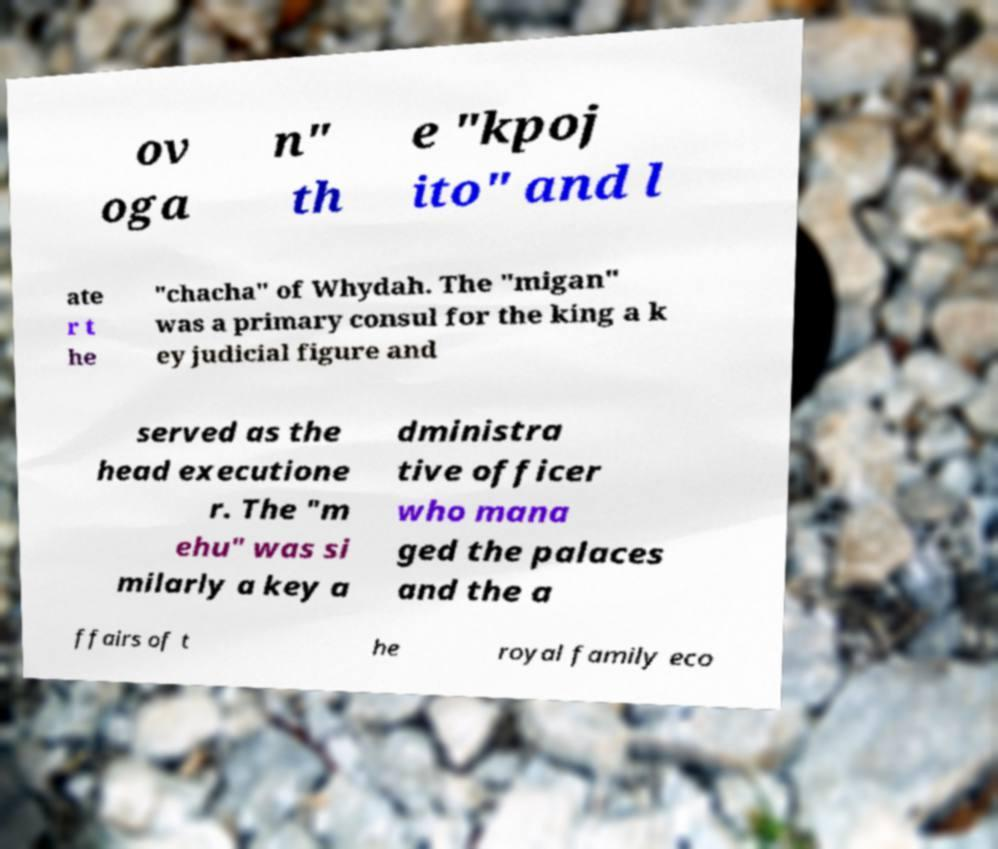For documentation purposes, I need the text within this image transcribed. Could you provide that? ov oga n" th e "kpoj ito" and l ate r t he "chacha" of Whydah. The "migan" was a primary consul for the king a k ey judicial figure and served as the head executione r. The "m ehu" was si milarly a key a dministra tive officer who mana ged the palaces and the a ffairs of t he royal family eco 